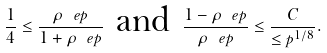Convert formula to latex. <formula><loc_0><loc_0><loc_500><loc_500>\frac { 1 } { 4 } \leq \frac { \rho _ { \ } e p } { 1 + \rho _ { \ } e p } \, \text { and } \, \frac { 1 - \rho _ { \ } e p } { \rho _ { \ } e p } \leq \frac { C } { \leq p ^ { 1 / 8 } } .</formula> 